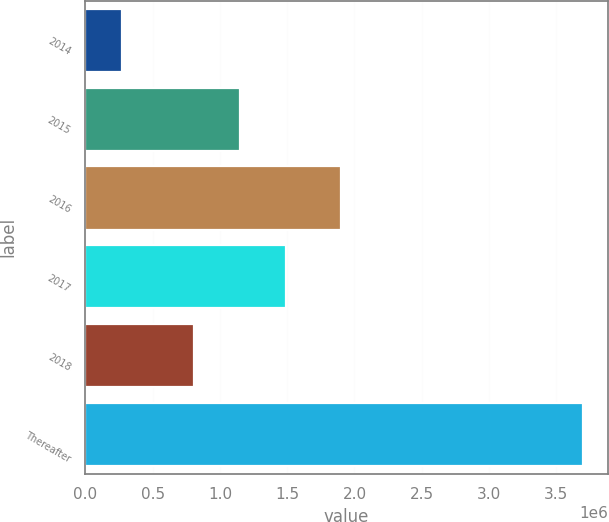Convert chart. <chart><loc_0><loc_0><loc_500><loc_500><bar_chart><fcel>2014<fcel>2015<fcel>2016<fcel>2017<fcel>2018<fcel>Thereafter<nl><fcel>274697<fcel>1.14876e+06<fcel>1.89755e+06<fcel>1.49118e+06<fcel>806339<fcel>3.69892e+06<nl></chart> 